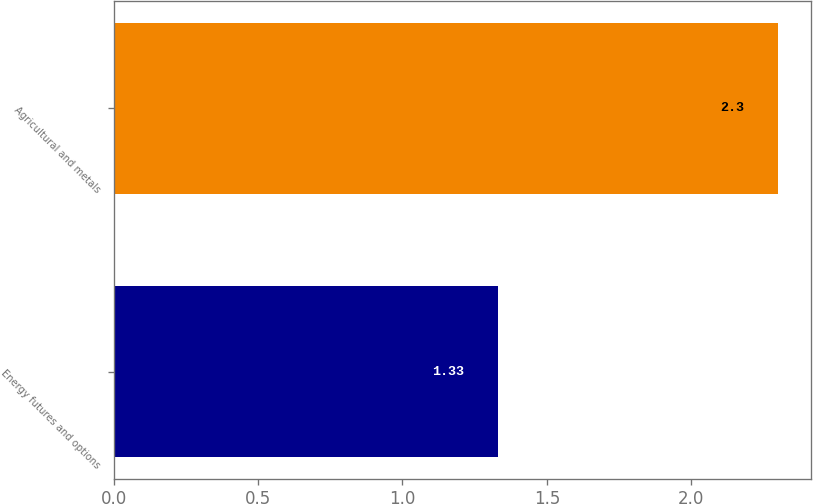<chart> <loc_0><loc_0><loc_500><loc_500><bar_chart><fcel>Energy futures and options<fcel>Agricultural and metals<nl><fcel>1.33<fcel>2.3<nl></chart> 